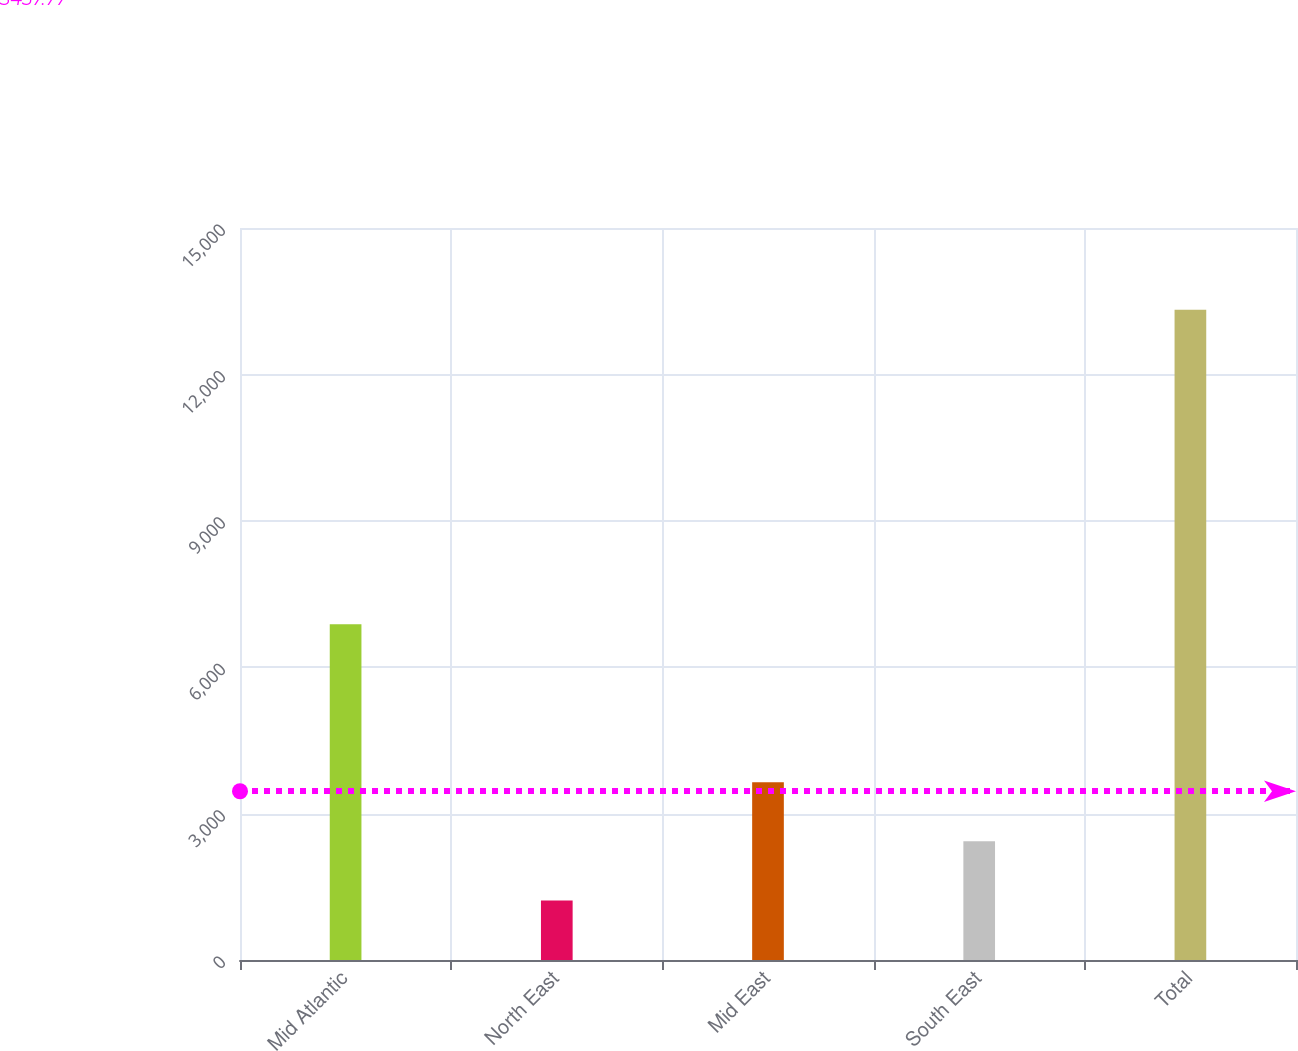Convert chart to OTSL. <chart><loc_0><loc_0><loc_500><loc_500><bar_chart><fcel>Mid Atlantic<fcel>North East<fcel>Mid East<fcel>South East<fcel>Total<nl><fcel>6879<fcel>1221<fcel>3642<fcel>2431.5<fcel>13326<nl></chart> 